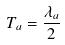<formula> <loc_0><loc_0><loc_500><loc_500>T _ { a } = \frac { \lambda _ { a } } { 2 }</formula> 